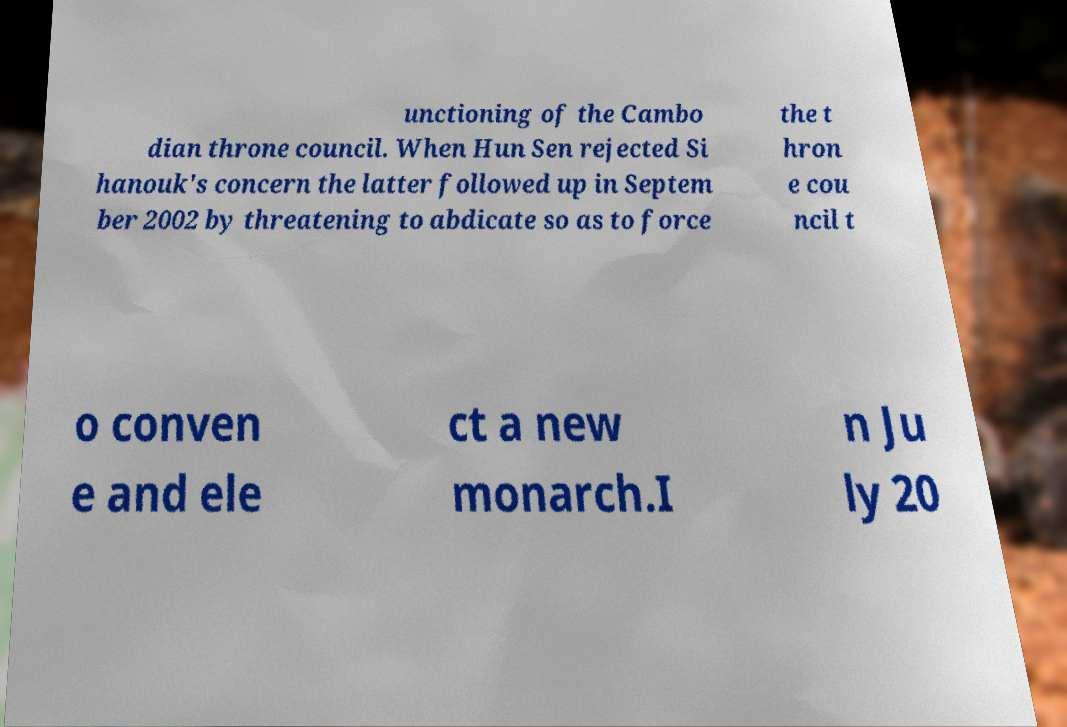What messages or text are displayed in this image? I need them in a readable, typed format. unctioning of the Cambo dian throne council. When Hun Sen rejected Si hanouk's concern the latter followed up in Septem ber 2002 by threatening to abdicate so as to force the t hron e cou ncil t o conven e and ele ct a new monarch.I n Ju ly 20 